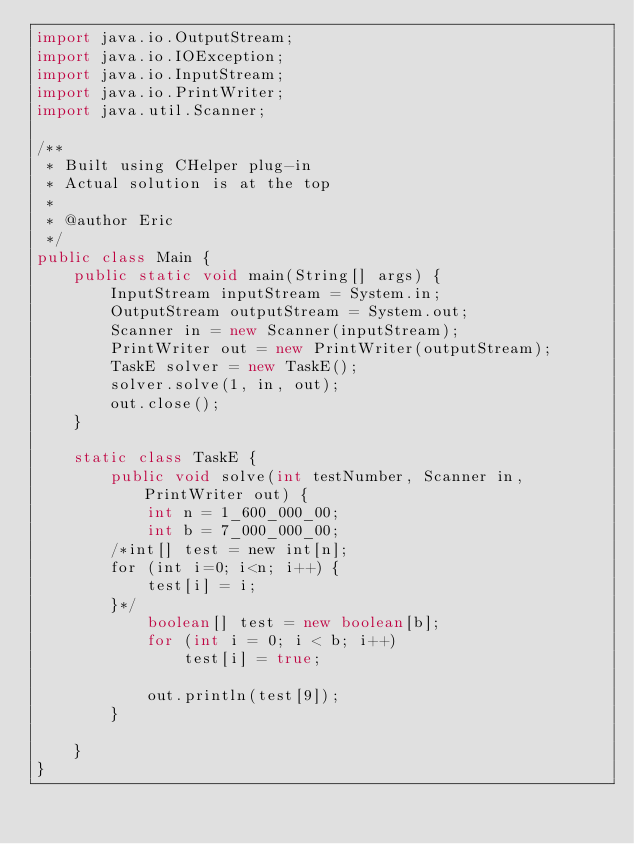Convert code to text. <code><loc_0><loc_0><loc_500><loc_500><_Java_>import java.io.OutputStream;
import java.io.IOException;
import java.io.InputStream;
import java.io.PrintWriter;
import java.util.Scanner;

/**
 * Built using CHelper plug-in
 * Actual solution is at the top
 *
 * @author Eric
 */
public class Main {
    public static void main(String[] args) {
        InputStream inputStream = System.in;
        OutputStream outputStream = System.out;
        Scanner in = new Scanner(inputStream);
        PrintWriter out = new PrintWriter(outputStream);
        TaskE solver = new TaskE();
        solver.solve(1, in, out);
        out.close();
    }

    static class TaskE {
        public void solve(int testNumber, Scanner in, PrintWriter out) {
            int n = 1_600_000_00;
            int b = 7_000_000_00;
        /*int[] test = new int[n];
        for (int i=0; i<n; i++) {
            test[i] = i;
        }*/
            boolean[] test = new boolean[b];
            for (int i = 0; i < b; i++)
                test[i] = true;

            out.println(test[9]);
        }

    }
}

</code> 